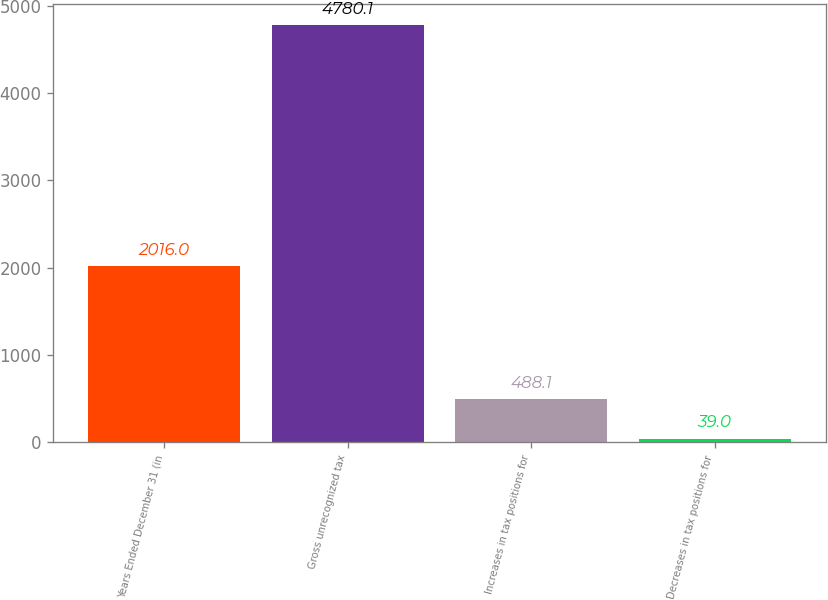<chart> <loc_0><loc_0><loc_500><loc_500><bar_chart><fcel>Years Ended December 31 (in<fcel>Gross unrecognized tax<fcel>Increases in tax positions for<fcel>Decreases in tax positions for<nl><fcel>2016<fcel>4780.1<fcel>488.1<fcel>39<nl></chart> 